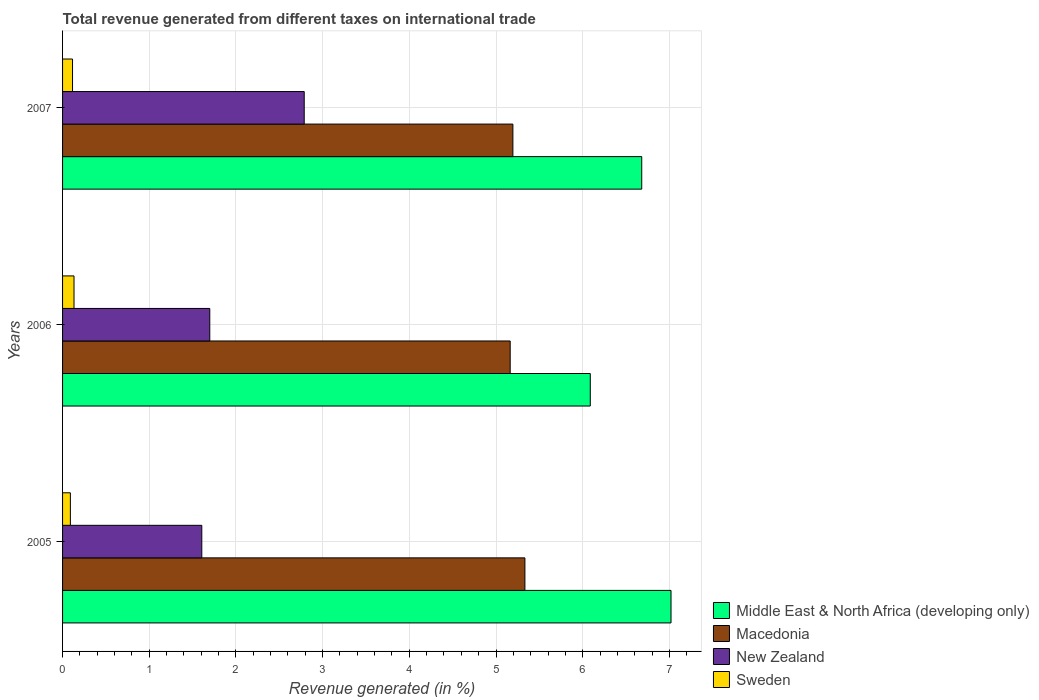How many different coloured bars are there?
Give a very brief answer. 4. How many groups of bars are there?
Provide a short and direct response. 3. Are the number of bars on each tick of the Y-axis equal?
Keep it short and to the point. Yes. What is the label of the 1st group of bars from the top?
Your answer should be compact. 2007. In how many cases, is the number of bars for a given year not equal to the number of legend labels?
Give a very brief answer. 0. What is the total revenue generated in Sweden in 2005?
Offer a terse response. 0.09. Across all years, what is the maximum total revenue generated in Sweden?
Give a very brief answer. 0.13. Across all years, what is the minimum total revenue generated in Sweden?
Give a very brief answer. 0.09. What is the total total revenue generated in Macedonia in the graph?
Offer a terse response. 15.69. What is the difference between the total revenue generated in Macedonia in 2006 and that in 2007?
Offer a terse response. -0.03. What is the difference between the total revenue generated in Middle East & North Africa (developing only) in 2005 and the total revenue generated in Macedonia in 2007?
Offer a very short reply. 1.82. What is the average total revenue generated in Macedonia per year?
Your answer should be compact. 5.23. In the year 2007, what is the difference between the total revenue generated in Macedonia and total revenue generated in Sweden?
Provide a short and direct response. 5.08. In how many years, is the total revenue generated in Sweden greater than 3 %?
Give a very brief answer. 0. What is the ratio of the total revenue generated in Sweden in 2005 to that in 2006?
Keep it short and to the point. 0.68. Is the total revenue generated in Middle East & North Africa (developing only) in 2005 less than that in 2006?
Give a very brief answer. No. Is the difference between the total revenue generated in Macedonia in 2005 and 2006 greater than the difference between the total revenue generated in Sweden in 2005 and 2006?
Your answer should be very brief. Yes. What is the difference between the highest and the second highest total revenue generated in Middle East & North Africa (developing only)?
Make the answer very short. 0.34. What is the difference between the highest and the lowest total revenue generated in Sweden?
Ensure brevity in your answer.  0.04. Is the sum of the total revenue generated in New Zealand in 2006 and 2007 greater than the maximum total revenue generated in Macedonia across all years?
Make the answer very short. No. What does the 2nd bar from the top in 2007 represents?
Keep it short and to the point. New Zealand. Is it the case that in every year, the sum of the total revenue generated in New Zealand and total revenue generated in Macedonia is greater than the total revenue generated in Sweden?
Your answer should be compact. Yes. How many bars are there?
Offer a very short reply. 12. Are the values on the major ticks of X-axis written in scientific E-notation?
Your response must be concise. No. How are the legend labels stacked?
Offer a very short reply. Vertical. What is the title of the graph?
Offer a terse response. Total revenue generated from different taxes on international trade. What is the label or title of the X-axis?
Ensure brevity in your answer.  Revenue generated (in %). What is the label or title of the Y-axis?
Your answer should be very brief. Years. What is the Revenue generated (in %) of Middle East & North Africa (developing only) in 2005?
Provide a succinct answer. 7.02. What is the Revenue generated (in %) of Macedonia in 2005?
Offer a terse response. 5.33. What is the Revenue generated (in %) in New Zealand in 2005?
Your response must be concise. 1.61. What is the Revenue generated (in %) in Sweden in 2005?
Offer a terse response. 0.09. What is the Revenue generated (in %) of Middle East & North Africa (developing only) in 2006?
Ensure brevity in your answer.  6.09. What is the Revenue generated (in %) of Macedonia in 2006?
Offer a very short reply. 5.16. What is the Revenue generated (in %) in New Zealand in 2006?
Give a very brief answer. 1.7. What is the Revenue generated (in %) in Sweden in 2006?
Keep it short and to the point. 0.13. What is the Revenue generated (in %) of Middle East & North Africa (developing only) in 2007?
Keep it short and to the point. 6.68. What is the Revenue generated (in %) of Macedonia in 2007?
Make the answer very short. 5.19. What is the Revenue generated (in %) of New Zealand in 2007?
Keep it short and to the point. 2.79. What is the Revenue generated (in %) of Sweden in 2007?
Provide a short and direct response. 0.11. Across all years, what is the maximum Revenue generated (in %) in Middle East & North Africa (developing only)?
Your answer should be very brief. 7.02. Across all years, what is the maximum Revenue generated (in %) of Macedonia?
Give a very brief answer. 5.33. Across all years, what is the maximum Revenue generated (in %) in New Zealand?
Offer a very short reply. 2.79. Across all years, what is the maximum Revenue generated (in %) of Sweden?
Keep it short and to the point. 0.13. Across all years, what is the minimum Revenue generated (in %) of Middle East & North Africa (developing only)?
Offer a terse response. 6.09. Across all years, what is the minimum Revenue generated (in %) of Macedonia?
Your answer should be very brief. 5.16. Across all years, what is the minimum Revenue generated (in %) of New Zealand?
Your answer should be very brief. 1.61. Across all years, what is the minimum Revenue generated (in %) of Sweden?
Make the answer very short. 0.09. What is the total Revenue generated (in %) of Middle East & North Africa (developing only) in the graph?
Keep it short and to the point. 19.79. What is the total Revenue generated (in %) of Macedonia in the graph?
Provide a short and direct response. 15.69. What is the total Revenue generated (in %) of New Zealand in the graph?
Make the answer very short. 6.09. What is the total Revenue generated (in %) in Sweden in the graph?
Make the answer very short. 0.34. What is the difference between the Revenue generated (in %) of Middle East & North Africa (developing only) in 2005 and that in 2006?
Provide a short and direct response. 0.93. What is the difference between the Revenue generated (in %) in Macedonia in 2005 and that in 2006?
Your answer should be compact. 0.17. What is the difference between the Revenue generated (in %) of New Zealand in 2005 and that in 2006?
Offer a very short reply. -0.09. What is the difference between the Revenue generated (in %) of Sweden in 2005 and that in 2006?
Keep it short and to the point. -0.04. What is the difference between the Revenue generated (in %) in Middle East & North Africa (developing only) in 2005 and that in 2007?
Your answer should be very brief. 0.34. What is the difference between the Revenue generated (in %) in Macedonia in 2005 and that in 2007?
Provide a succinct answer. 0.14. What is the difference between the Revenue generated (in %) of New Zealand in 2005 and that in 2007?
Give a very brief answer. -1.18. What is the difference between the Revenue generated (in %) of Sweden in 2005 and that in 2007?
Provide a short and direct response. -0.02. What is the difference between the Revenue generated (in %) in Middle East & North Africa (developing only) in 2006 and that in 2007?
Provide a short and direct response. -0.59. What is the difference between the Revenue generated (in %) of Macedonia in 2006 and that in 2007?
Keep it short and to the point. -0.03. What is the difference between the Revenue generated (in %) in New Zealand in 2006 and that in 2007?
Your answer should be very brief. -1.09. What is the difference between the Revenue generated (in %) in Sweden in 2006 and that in 2007?
Make the answer very short. 0.02. What is the difference between the Revenue generated (in %) in Middle East & North Africa (developing only) in 2005 and the Revenue generated (in %) in Macedonia in 2006?
Make the answer very short. 1.86. What is the difference between the Revenue generated (in %) of Middle East & North Africa (developing only) in 2005 and the Revenue generated (in %) of New Zealand in 2006?
Ensure brevity in your answer.  5.32. What is the difference between the Revenue generated (in %) in Middle East & North Africa (developing only) in 2005 and the Revenue generated (in %) in Sweden in 2006?
Your answer should be very brief. 6.89. What is the difference between the Revenue generated (in %) in Macedonia in 2005 and the Revenue generated (in %) in New Zealand in 2006?
Offer a very short reply. 3.64. What is the difference between the Revenue generated (in %) of Macedonia in 2005 and the Revenue generated (in %) of Sweden in 2006?
Provide a short and direct response. 5.2. What is the difference between the Revenue generated (in %) in New Zealand in 2005 and the Revenue generated (in %) in Sweden in 2006?
Your answer should be very brief. 1.47. What is the difference between the Revenue generated (in %) of Middle East & North Africa (developing only) in 2005 and the Revenue generated (in %) of Macedonia in 2007?
Give a very brief answer. 1.82. What is the difference between the Revenue generated (in %) of Middle East & North Africa (developing only) in 2005 and the Revenue generated (in %) of New Zealand in 2007?
Your response must be concise. 4.23. What is the difference between the Revenue generated (in %) of Middle East & North Africa (developing only) in 2005 and the Revenue generated (in %) of Sweden in 2007?
Offer a terse response. 6.9. What is the difference between the Revenue generated (in %) of Macedonia in 2005 and the Revenue generated (in %) of New Zealand in 2007?
Provide a succinct answer. 2.55. What is the difference between the Revenue generated (in %) in Macedonia in 2005 and the Revenue generated (in %) in Sweden in 2007?
Ensure brevity in your answer.  5.22. What is the difference between the Revenue generated (in %) in New Zealand in 2005 and the Revenue generated (in %) in Sweden in 2007?
Give a very brief answer. 1.49. What is the difference between the Revenue generated (in %) of Middle East & North Africa (developing only) in 2006 and the Revenue generated (in %) of Macedonia in 2007?
Offer a very short reply. 0.89. What is the difference between the Revenue generated (in %) of Middle East & North Africa (developing only) in 2006 and the Revenue generated (in %) of New Zealand in 2007?
Your response must be concise. 3.3. What is the difference between the Revenue generated (in %) in Middle East & North Africa (developing only) in 2006 and the Revenue generated (in %) in Sweden in 2007?
Offer a terse response. 5.97. What is the difference between the Revenue generated (in %) in Macedonia in 2006 and the Revenue generated (in %) in New Zealand in 2007?
Keep it short and to the point. 2.38. What is the difference between the Revenue generated (in %) in Macedonia in 2006 and the Revenue generated (in %) in Sweden in 2007?
Your response must be concise. 5.05. What is the difference between the Revenue generated (in %) in New Zealand in 2006 and the Revenue generated (in %) in Sweden in 2007?
Provide a succinct answer. 1.58. What is the average Revenue generated (in %) in Middle East & North Africa (developing only) per year?
Make the answer very short. 6.6. What is the average Revenue generated (in %) of Macedonia per year?
Your answer should be compact. 5.23. What is the average Revenue generated (in %) in New Zealand per year?
Offer a terse response. 2.03. What is the average Revenue generated (in %) in Sweden per year?
Provide a succinct answer. 0.11. In the year 2005, what is the difference between the Revenue generated (in %) of Middle East & North Africa (developing only) and Revenue generated (in %) of Macedonia?
Give a very brief answer. 1.69. In the year 2005, what is the difference between the Revenue generated (in %) of Middle East & North Africa (developing only) and Revenue generated (in %) of New Zealand?
Offer a very short reply. 5.41. In the year 2005, what is the difference between the Revenue generated (in %) of Middle East & North Africa (developing only) and Revenue generated (in %) of Sweden?
Offer a very short reply. 6.93. In the year 2005, what is the difference between the Revenue generated (in %) in Macedonia and Revenue generated (in %) in New Zealand?
Make the answer very short. 3.73. In the year 2005, what is the difference between the Revenue generated (in %) in Macedonia and Revenue generated (in %) in Sweden?
Offer a very short reply. 5.24. In the year 2005, what is the difference between the Revenue generated (in %) in New Zealand and Revenue generated (in %) in Sweden?
Offer a very short reply. 1.52. In the year 2006, what is the difference between the Revenue generated (in %) in Middle East & North Africa (developing only) and Revenue generated (in %) in Macedonia?
Ensure brevity in your answer.  0.92. In the year 2006, what is the difference between the Revenue generated (in %) of Middle East & North Africa (developing only) and Revenue generated (in %) of New Zealand?
Provide a succinct answer. 4.39. In the year 2006, what is the difference between the Revenue generated (in %) of Middle East & North Africa (developing only) and Revenue generated (in %) of Sweden?
Your answer should be compact. 5.96. In the year 2006, what is the difference between the Revenue generated (in %) of Macedonia and Revenue generated (in %) of New Zealand?
Make the answer very short. 3.47. In the year 2006, what is the difference between the Revenue generated (in %) of Macedonia and Revenue generated (in %) of Sweden?
Make the answer very short. 5.03. In the year 2006, what is the difference between the Revenue generated (in %) of New Zealand and Revenue generated (in %) of Sweden?
Your answer should be very brief. 1.57. In the year 2007, what is the difference between the Revenue generated (in %) in Middle East & North Africa (developing only) and Revenue generated (in %) in Macedonia?
Offer a terse response. 1.49. In the year 2007, what is the difference between the Revenue generated (in %) of Middle East & North Africa (developing only) and Revenue generated (in %) of New Zealand?
Offer a terse response. 3.89. In the year 2007, what is the difference between the Revenue generated (in %) in Middle East & North Africa (developing only) and Revenue generated (in %) in Sweden?
Provide a succinct answer. 6.57. In the year 2007, what is the difference between the Revenue generated (in %) of Macedonia and Revenue generated (in %) of New Zealand?
Make the answer very short. 2.41. In the year 2007, what is the difference between the Revenue generated (in %) in Macedonia and Revenue generated (in %) in Sweden?
Offer a terse response. 5.08. In the year 2007, what is the difference between the Revenue generated (in %) in New Zealand and Revenue generated (in %) in Sweden?
Offer a very short reply. 2.67. What is the ratio of the Revenue generated (in %) in Middle East & North Africa (developing only) in 2005 to that in 2006?
Your answer should be compact. 1.15. What is the ratio of the Revenue generated (in %) of Macedonia in 2005 to that in 2006?
Offer a very short reply. 1.03. What is the ratio of the Revenue generated (in %) of New Zealand in 2005 to that in 2006?
Give a very brief answer. 0.95. What is the ratio of the Revenue generated (in %) in Sweden in 2005 to that in 2006?
Your answer should be compact. 0.68. What is the ratio of the Revenue generated (in %) in Middle East & North Africa (developing only) in 2005 to that in 2007?
Provide a succinct answer. 1.05. What is the ratio of the Revenue generated (in %) of Macedonia in 2005 to that in 2007?
Keep it short and to the point. 1.03. What is the ratio of the Revenue generated (in %) of New Zealand in 2005 to that in 2007?
Keep it short and to the point. 0.58. What is the ratio of the Revenue generated (in %) of Sweden in 2005 to that in 2007?
Ensure brevity in your answer.  0.78. What is the ratio of the Revenue generated (in %) of Middle East & North Africa (developing only) in 2006 to that in 2007?
Your answer should be compact. 0.91. What is the ratio of the Revenue generated (in %) of Macedonia in 2006 to that in 2007?
Ensure brevity in your answer.  0.99. What is the ratio of the Revenue generated (in %) of New Zealand in 2006 to that in 2007?
Make the answer very short. 0.61. What is the ratio of the Revenue generated (in %) in Sweden in 2006 to that in 2007?
Keep it short and to the point. 1.15. What is the difference between the highest and the second highest Revenue generated (in %) in Middle East & North Africa (developing only)?
Make the answer very short. 0.34. What is the difference between the highest and the second highest Revenue generated (in %) in Macedonia?
Keep it short and to the point. 0.14. What is the difference between the highest and the second highest Revenue generated (in %) of New Zealand?
Offer a very short reply. 1.09. What is the difference between the highest and the second highest Revenue generated (in %) in Sweden?
Your answer should be very brief. 0.02. What is the difference between the highest and the lowest Revenue generated (in %) of Middle East & North Africa (developing only)?
Make the answer very short. 0.93. What is the difference between the highest and the lowest Revenue generated (in %) of Macedonia?
Provide a succinct answer. 0.17. What is the difference between the highest and the lowest Revenue generated (in %) of New Zealand?
Provide a succinct answer. 1.18. What is the difference between the highest and the lowest Revenue generated (in %) in Sweden?
Your response must be concise. 0.04. 